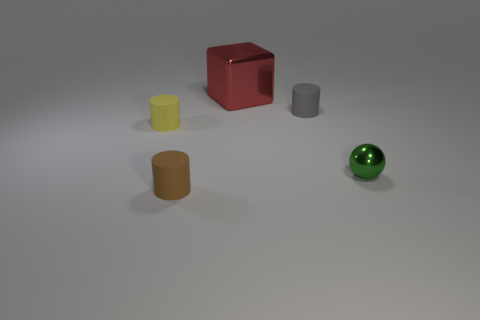If this was an art installation, what could be the artist's message? If interpreted as an art installation, the composition of these variously colored and shaped objects might symbolize the diversity of individuals in society. The placement of the objects, separate but within the same shared space, could suggest themes of coexistence and individuality within a community. 